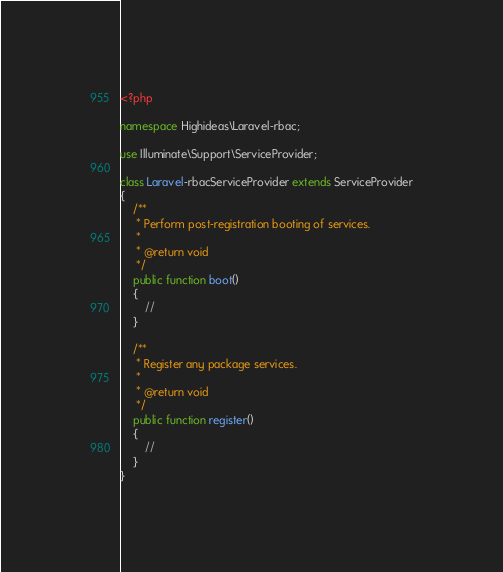Convert code to text. <code><loc_0><loc_0><loc_500><loc_500><_PHP_><?php

namespace Highideas\Laravel-rbac;

use Illuminate\Support\ServiceProvider;

class Laravel-rbacServiceProvider extends ServiceProvider
{
    /**
     * Perform post-registration booting of services.
     *
     * @return void
     */
    public function boot()
    {
        //
    }

    /**
     * Register any package services.
     *
     * @return void
     */
    public function register()
    {
        //
    }
}</code> 